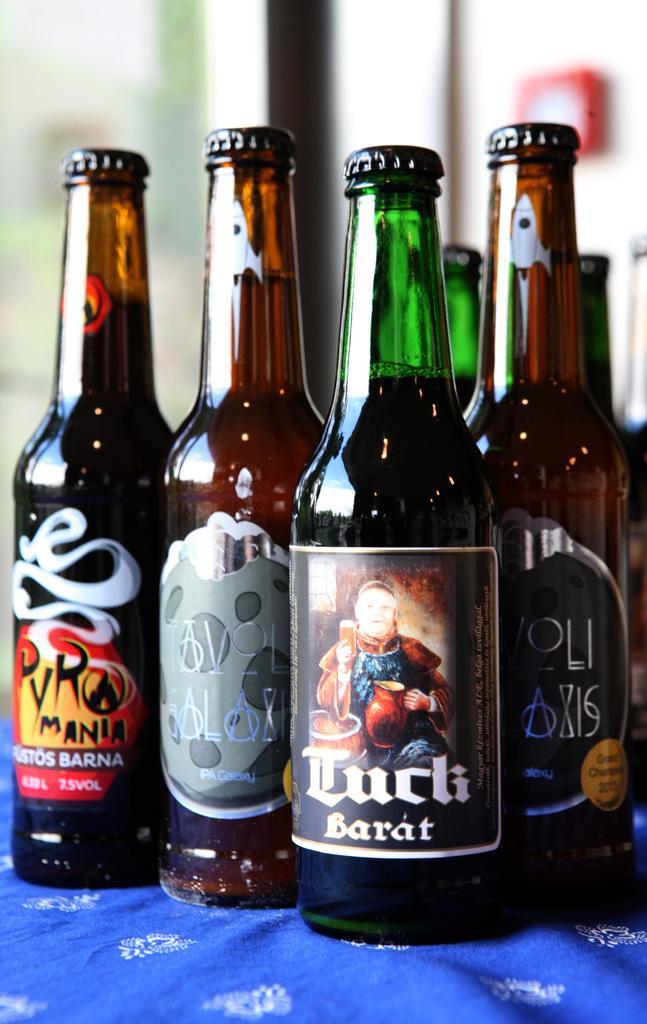Please provide a concise description of this image. In this image there are bottles. 